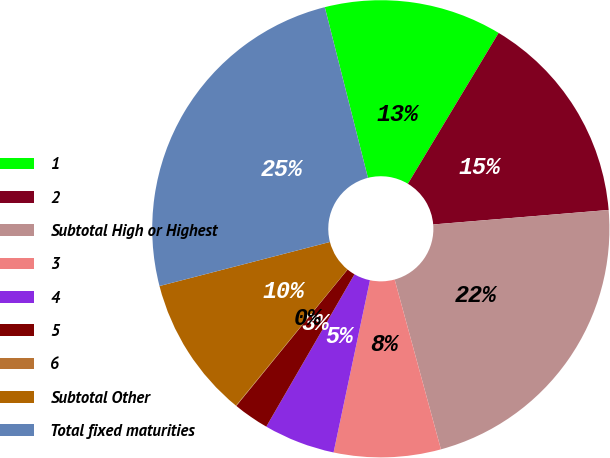Convert chart to OTSL. <chart><loc_0><loc_0><loc_500><loc_500><pie_chart><fcel>1<fcel>2<fcel>Subtotal High or Highest<fcel>3<fcel>4<fcel>5<fcel>6<fcel>Subtotal Other<fcel>Total fixed maturities<nl><fcel>12.56%<fcel>15.07%<fcel>22.08%<fcel>7.55%<fcel>5.04%<fcel>2.54%<fcel>0.03%<fcel>10.05%<fcel>25.09%<nl></chart> 